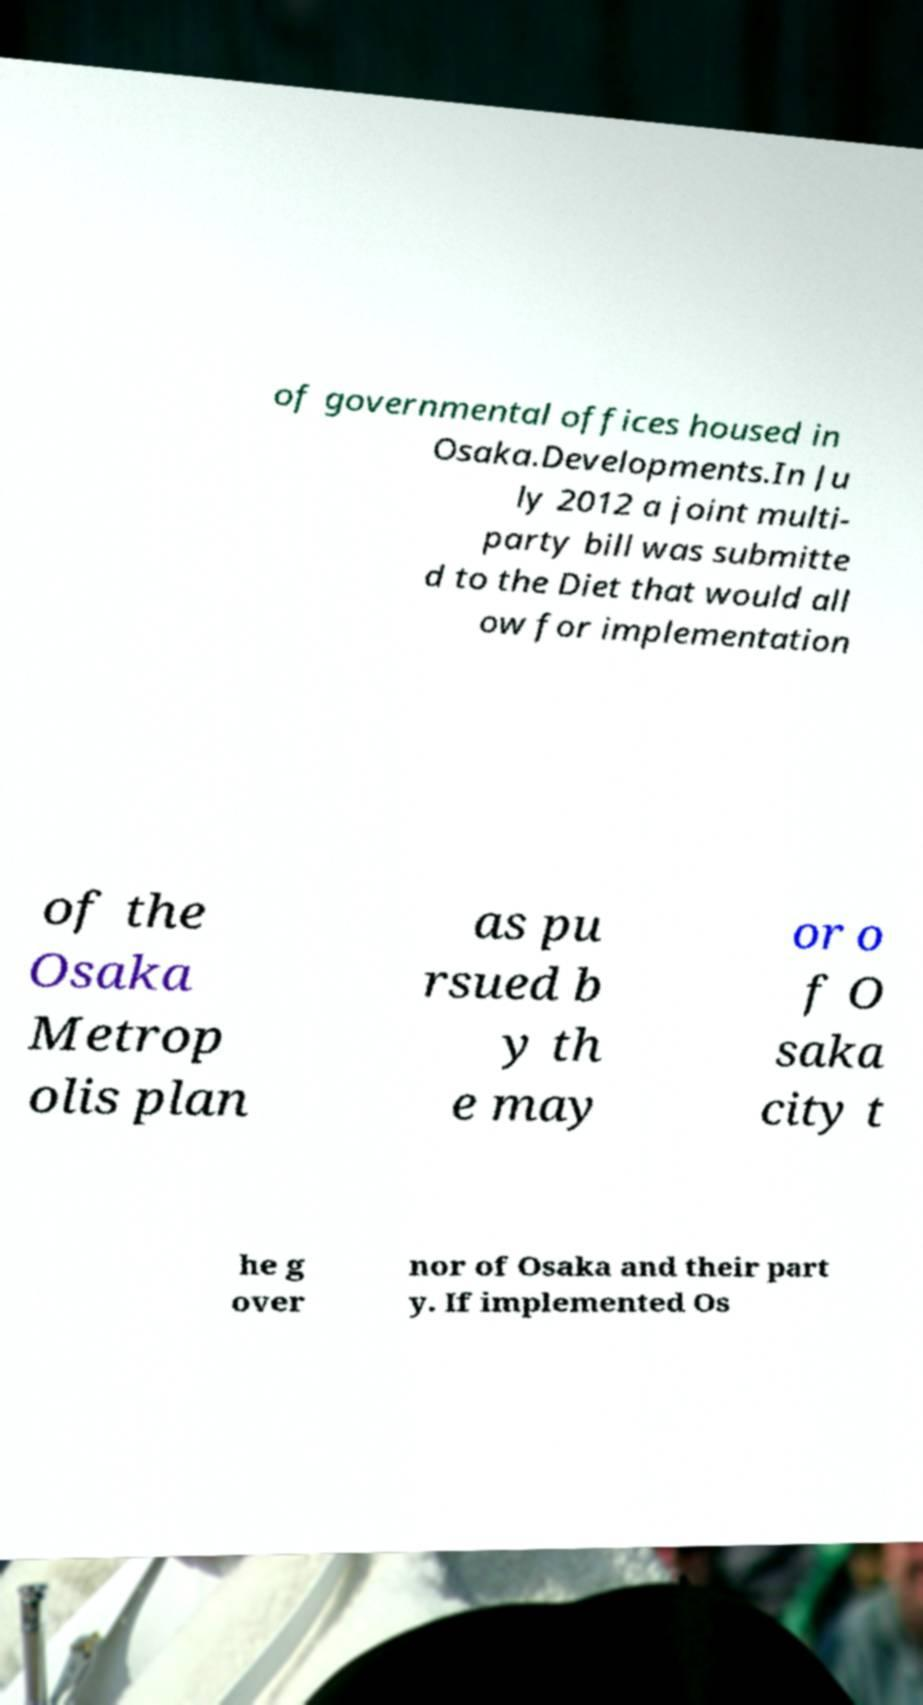Please identify and transcribe the text found in this image. of governmental offices housed in Osaka.Developments.In Ju ly 2012 a joint multi- party bill was submitte d to the Diet that would all ow for implementation of the Osaka Metrop olis plan as pu rsued b y th e may or o f O saka city t he g over nor of Osaka and their part y. If implemented Os 